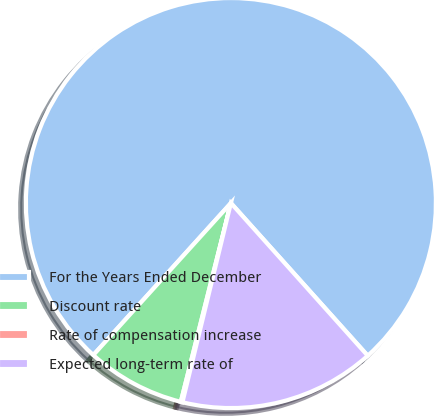Convert chart. <chart><loc_0><loc_0><loc_500><loc_500><pie_chart><fcel>For the Years Ended December<fcel>Discount rate<fcel>Rate of compensation increase<fcel>Expected long-term rate of<nl><fcel>76.66%<fcel>7.78%<fcel>0.13%<fcel>15.43%<nl></chart> 